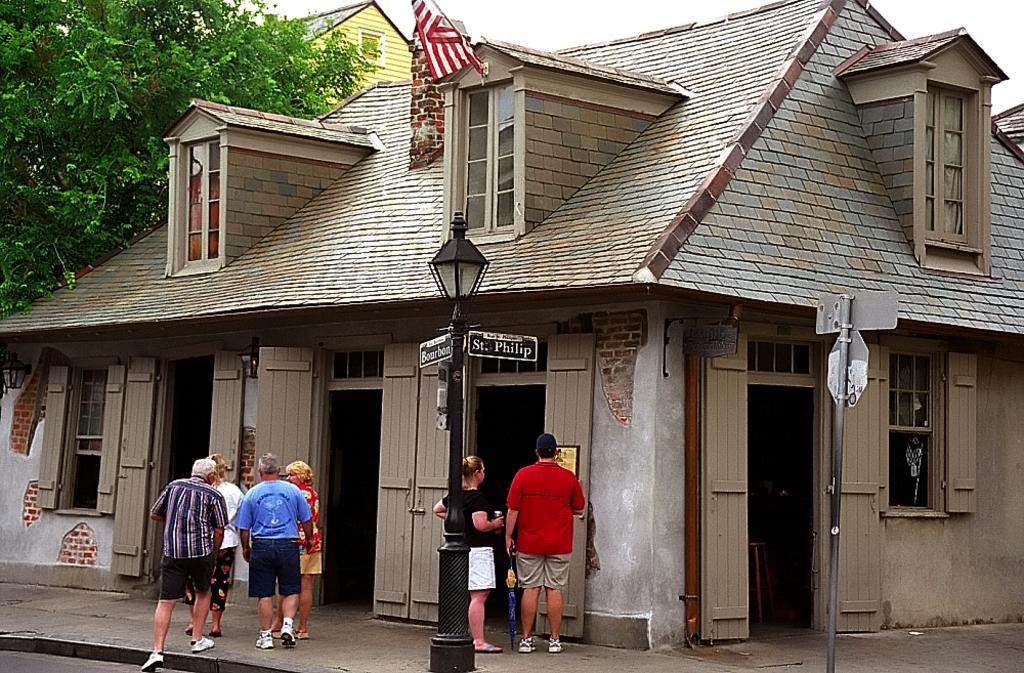Could you give a brief overview of what you see in this image? In this image we can see persons standing on the floor, street poles, street lights, sign boards, building, trees and sky. 